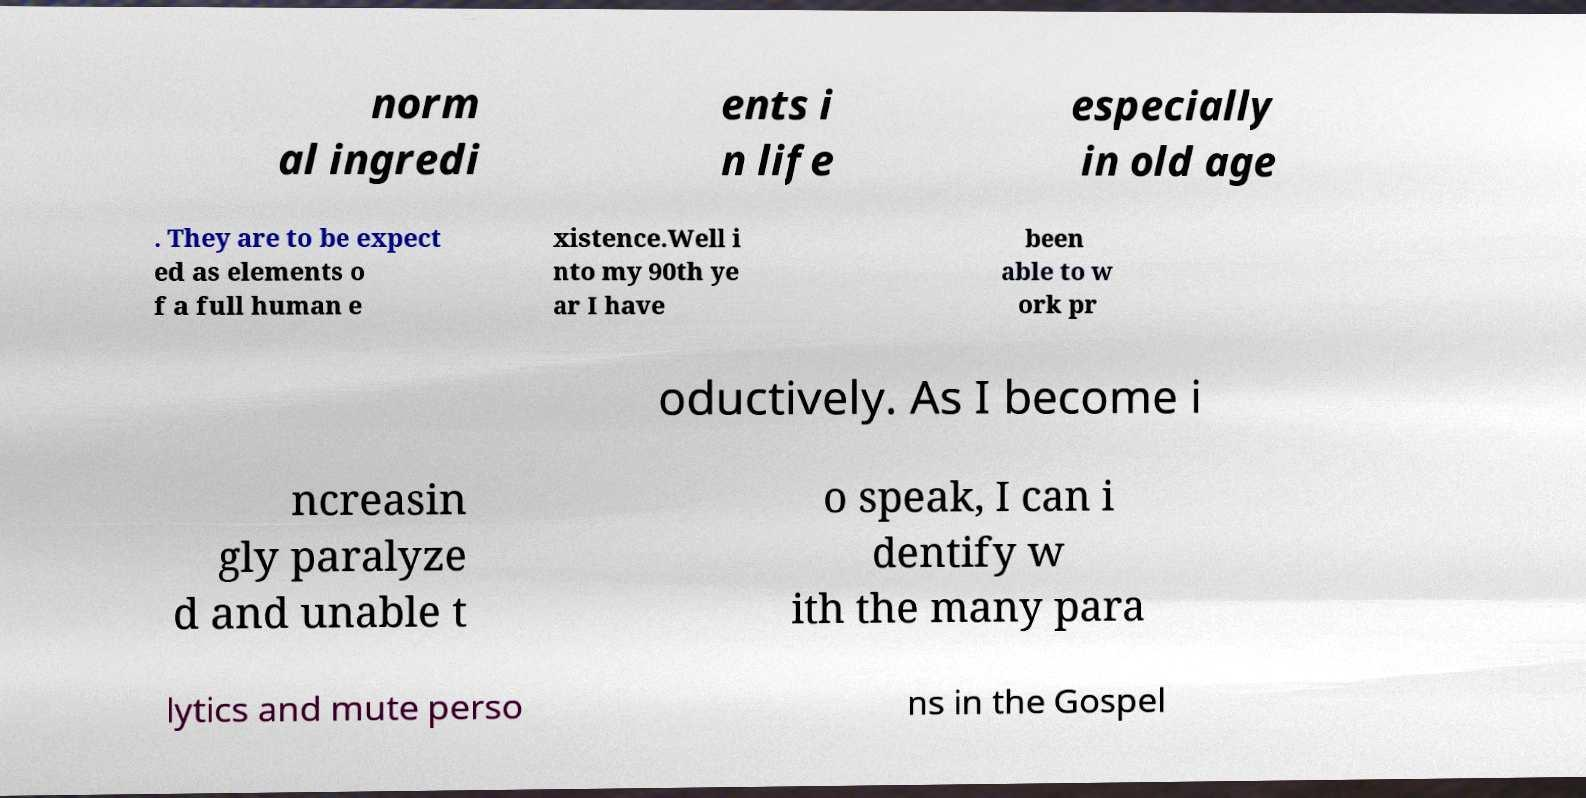What messages or text are displayed in this image? I need them in a readable, typed format. norm al ingredi ents i n life especially in old age . They are to be expect ed as elements o f a full human e xistence.Well i nto my 90th ye ar I have been able to w ork pr oductively. As I become i ncreasin gly paralyze d and unable t o speak, I can i dentify w ith the many para lytics and mute perso ns in the Gospel 